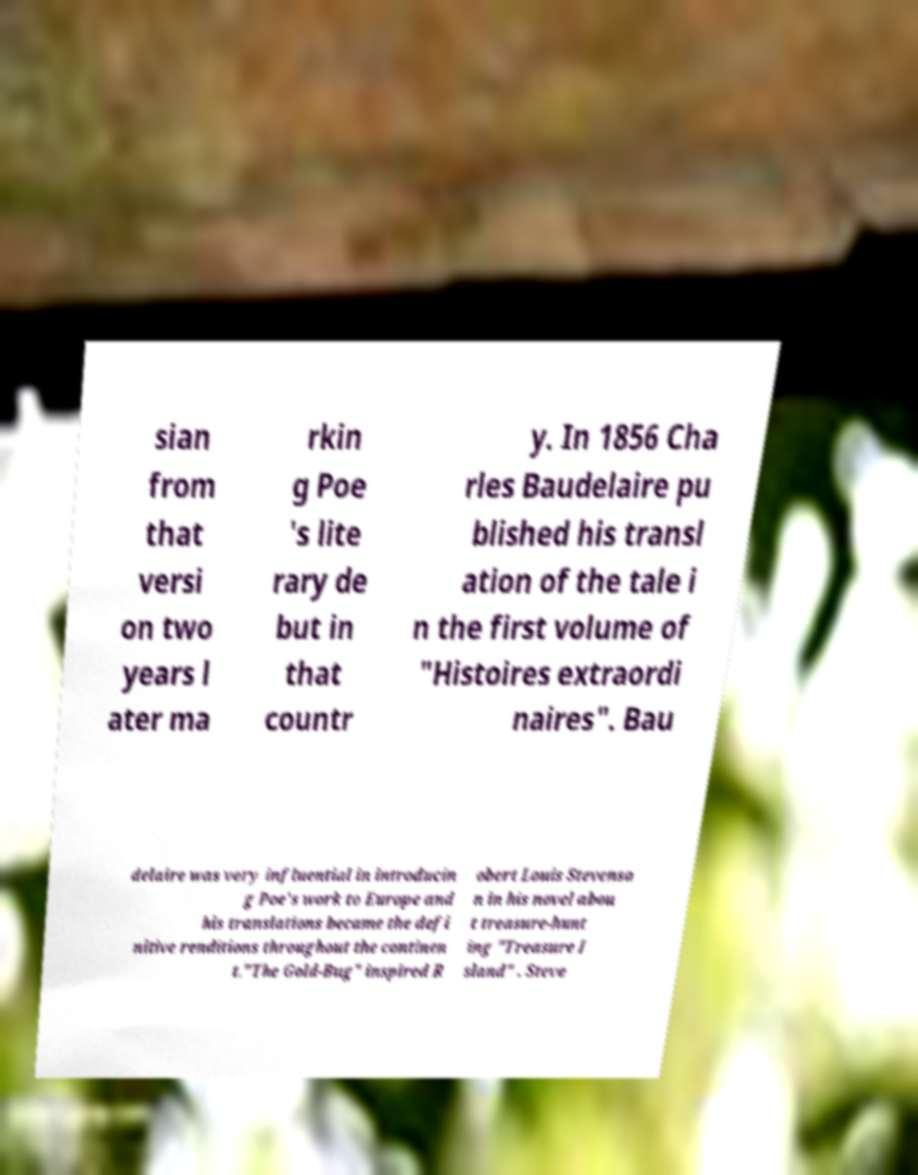What messages or text are displayed in this image? I need them in a readable, typed format. sian from that versi on two years l ater ma rkin g Poe 's lite rary de but in that countr y. In 1856 Cha rles Baudelaire pu blished his transl ation of the tale i n the first volume of "Histoires extraordi naires". Bau delaire was very influential in introducin g Poe's work to Europe and his translations became the defi nitive renditions throughout the continen t."The Gold-Bug" inspired R obert Louis Stevenso n in his novel abou t treasure-hunt ing "Treasure I sland" . Steve 